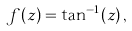<formula> <loc_0><loc_0><loc_500><loc_500>f ( z ) = \tan ^ { - 1 } ( z ) \, ,</formula> 